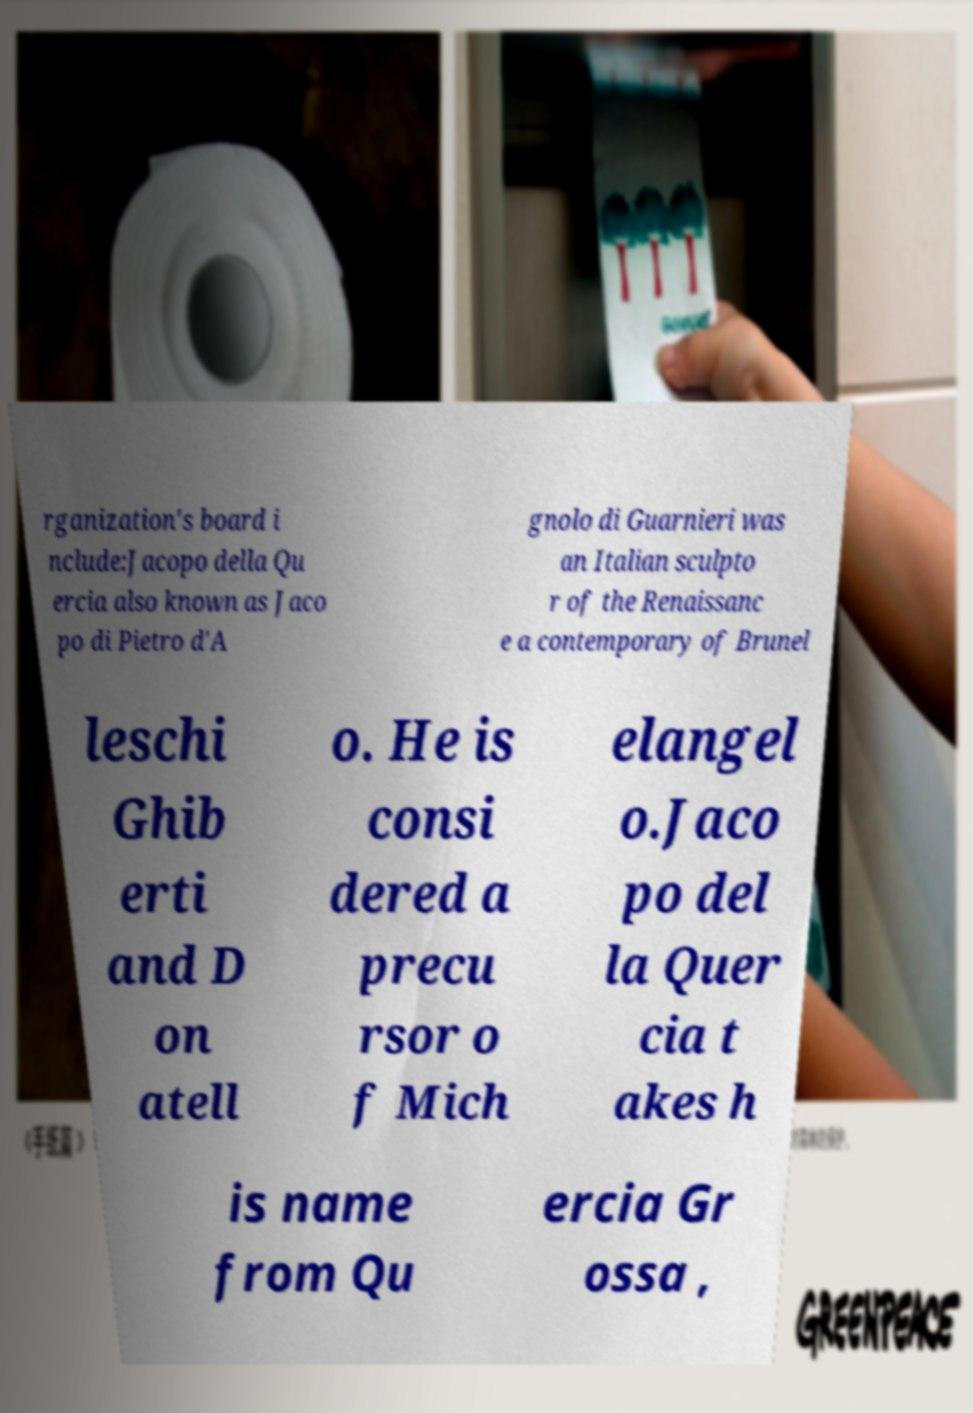Could you extract and type out the text from this image? rganization's board i nclude:Jacopo della Qu ercia also known as Jaco po di Pietro d'A gnolo di Guarnieri was an Italian sculpto r of the Renaissanc e a contemporary of Brunel leschi Ghib erti and D on atell o. He is consi dered a precu rsor o f Mich elangel o.Jaco po del la Quer cia t akes h is name from Qu ercia Gr ossa , 